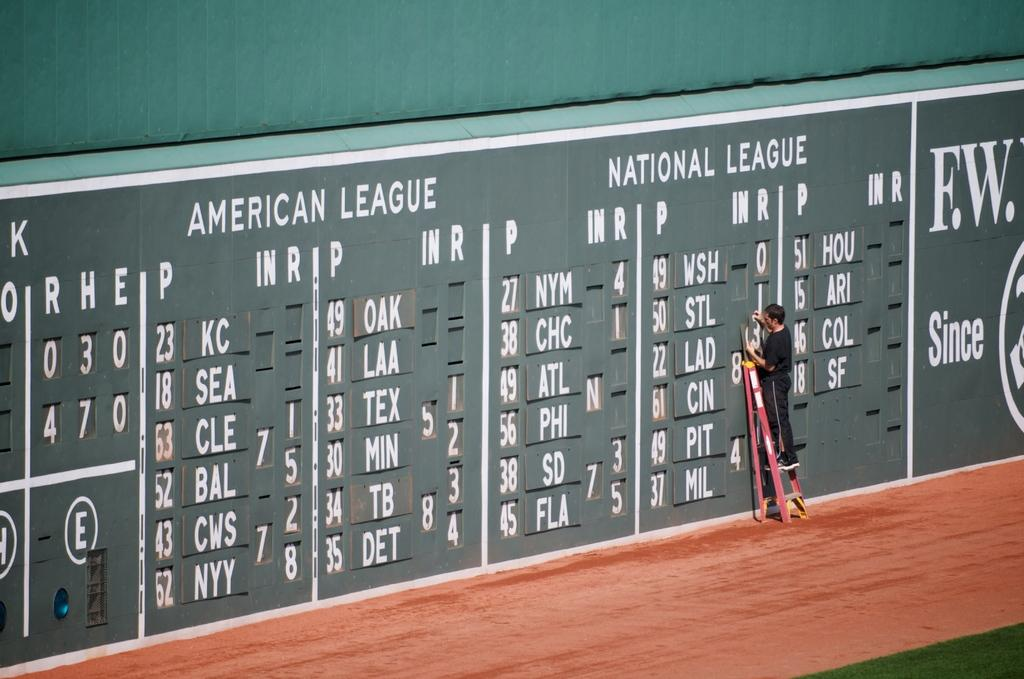<image>
Render a clear and concise summary of the photo. A man with a ladder changes numbers on a green scoreboard for the American league and National League. 